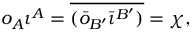<formula> <loc_0><loc_0><loc_500><loc_500>o _ { A } \iota ^ { A } = \overline { { { ( \bar { o } _ { B ^ { \prime } } \bar { \iota } ^ { B ^ { \prime } } ) } } } = \chi ,</formula> 